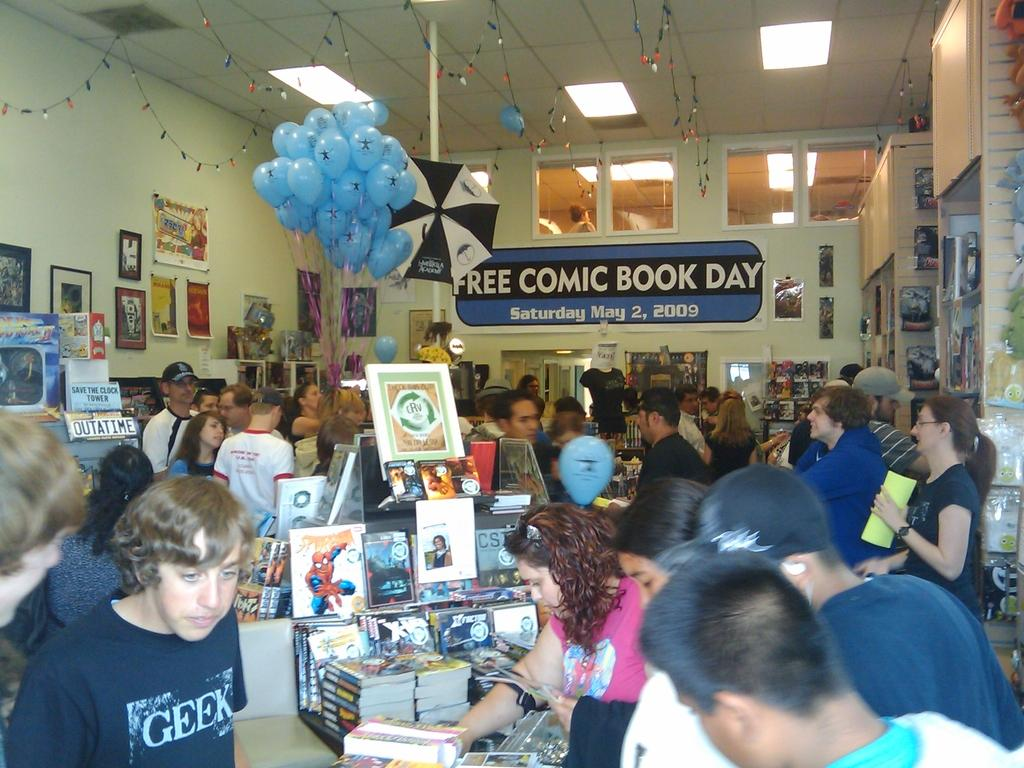What is the main subject of the image? The main subject of the image is a group of persons standing. What objects can be seen in the image besides the persons? There are books, balloons, lights, and notice papers in the image. What is the background of the image? The wall is visible in the image. What is your uncle doing with the balloon in the image? There is no uncle present in the image, and therefore no such activity can be observed. How many arms does the person in the image have? The image does not provide enough detail to determine the number of arms each person has. 